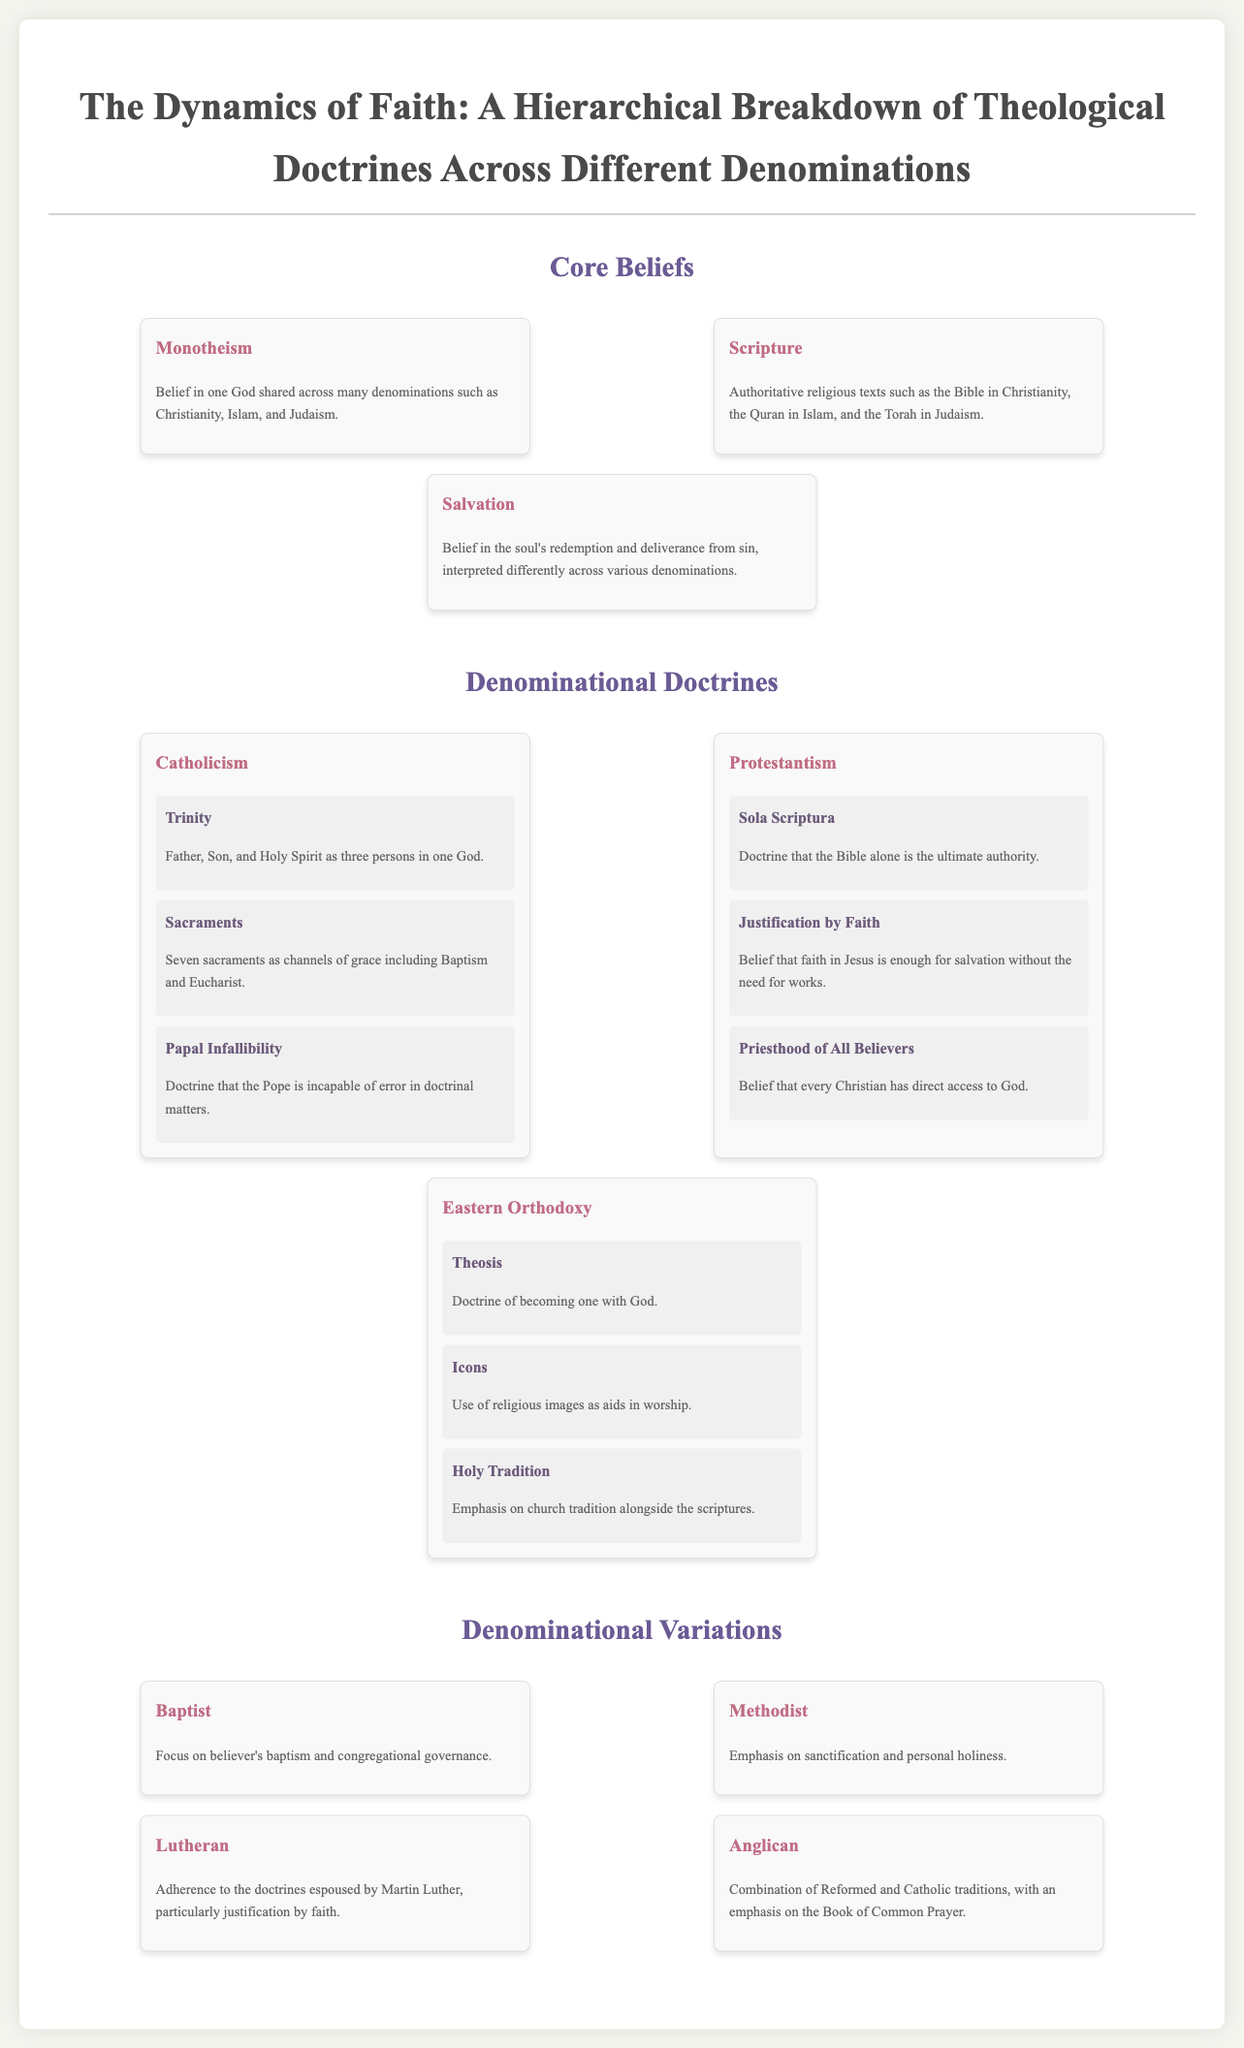What are the three persons in the Trinity? The Trinity in Catholicism consists of the Father, Son, and Holy Spirit.
Answer: Father, Son, and Holy Spirit What is the ultimate authority in Protestantism? The doctrine of Sola Scriptura states that the Bible alone is the ultimate authority in Protestantism.
Answer: Bible What sacrament is associated with channels of grace in Catholicism? One of the sacraments in Catholicism is Baptism, which is considered a channel of grace.
Answer: Baptism Which doctrine emphasizes becoming one with God? Theosis is the doctrine that emphasizes becoming one with God in Eastern Orthodoxy.
Answer: Theosis What is the focus of Baptist governance? Baptist governance focuses on believer's baptism and congregational governance.
Answer: Congregational governance Which denomination emphasizes sanctification? The Methodist denomination emphasizes sanctification and personal holiness.
Answer: Methodist How many sacraments are recognized by Catholicism? Catholicism recognizes seven sacraments as channels of grace.
Answer: Seven What theological concept is associated with Martin Luther? The adherence to the doctrines espoused by Martin Luther, particularly justification by faith, is core to Lutheran beliefs.
Answer: Justification by Faith What tradition is emphasized alongside scriptures in Eastern Orthodoxy? Holy Tradition is emphasized alongside the scriptures in Eastern Orthodoxy.
Answer: Holy Tradition 